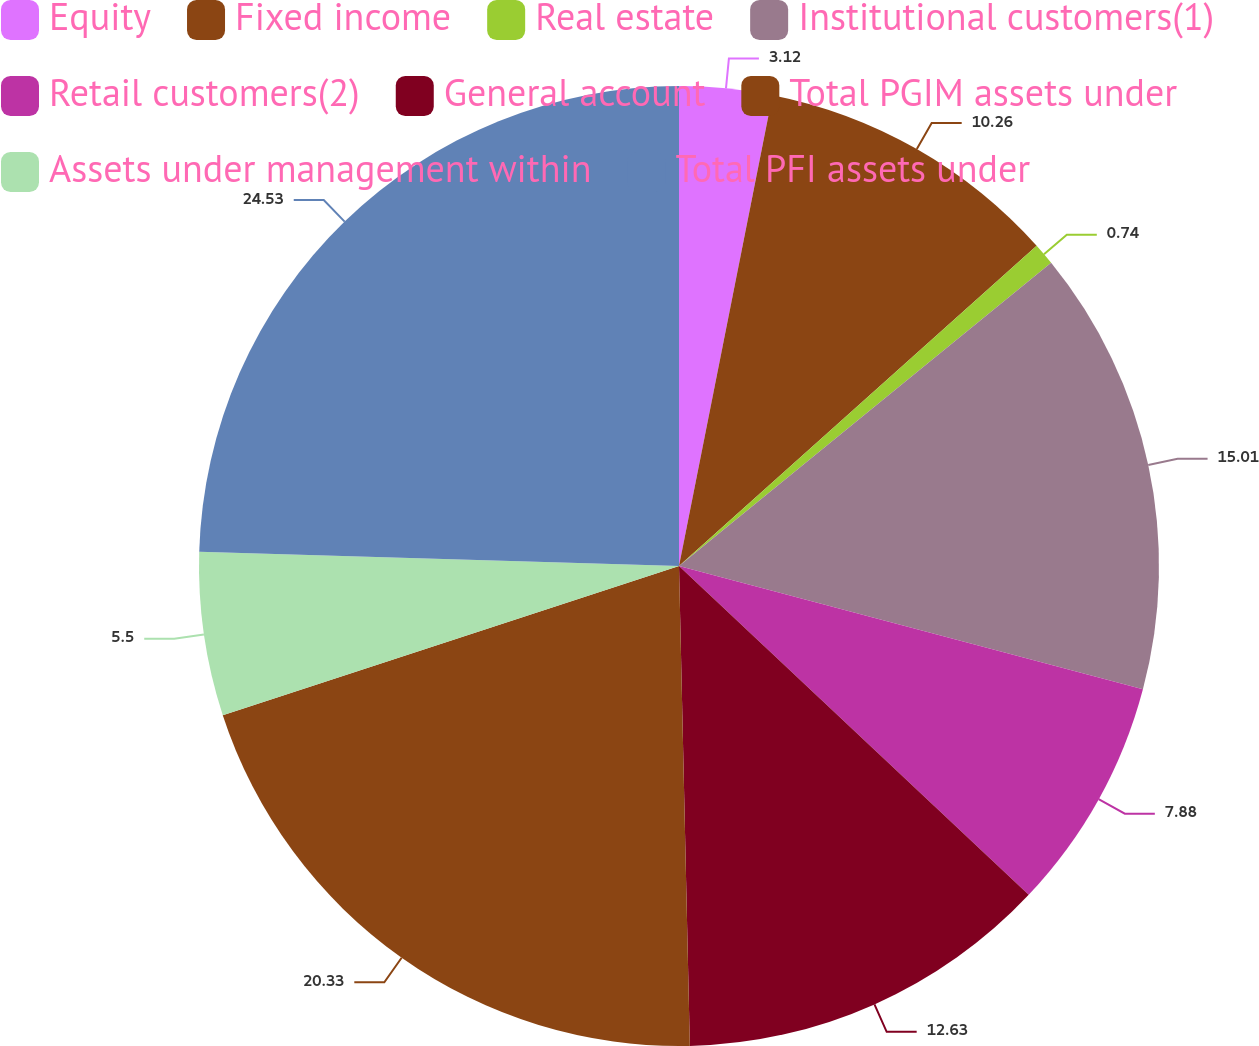<chart> <loc_0><loc_0><loc_500><loc_500><pie_chart><fcel>Equity<fcel>Fixed income<fcel>Real estate<fcel>Institutional customers(1)<fcel>Retail customers(2)<fcel>General account<fcel>Total PGIM assets under<fcel>Assets under management within<fcel>Total PFI assets under<nl><fcel>3.12%<fcel>10.26%<fcel>0.74%<fcel>15.01%<fcel>7.88%<fcel>12.63%<fcel>20.33%<fcel>5.5%<fcel>24.53%<nl></chart> 